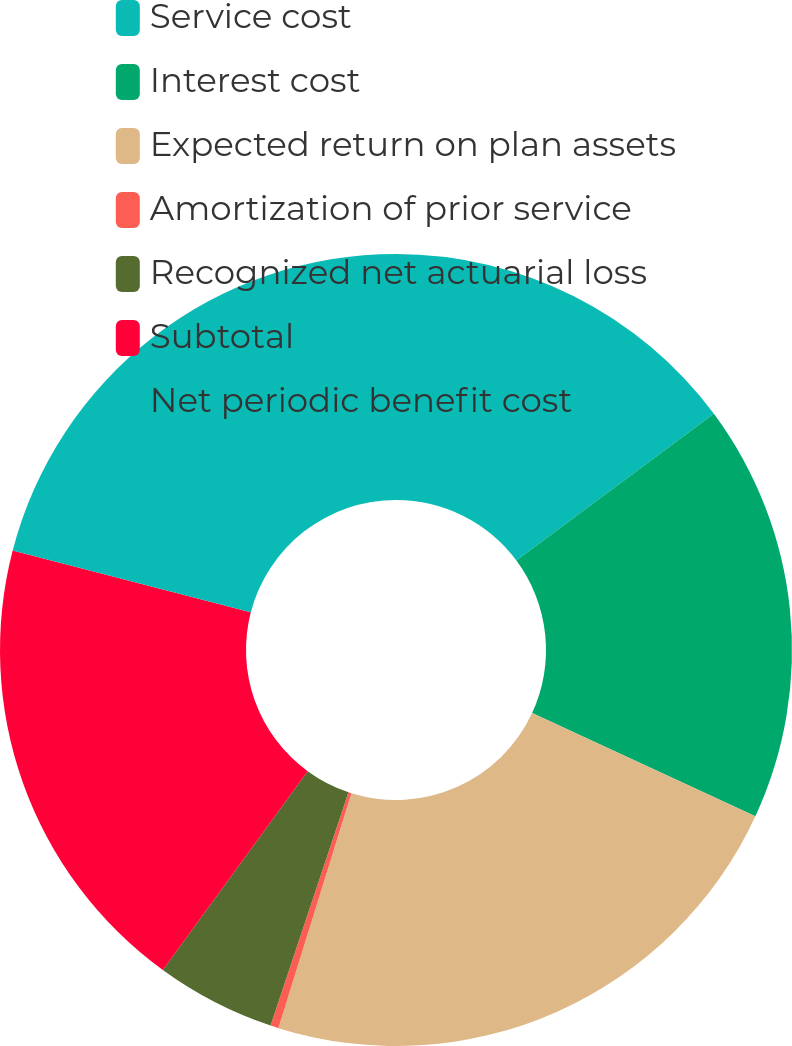Convert chart. <chart><loc_0><loc_0><loc_500><loc_500><pie_chart><fcel>Service cost<fcel>Interest cost<fcel>Expected return on plan assets<fcel>Amortization of prior service<fcel>Recognized net actuarial loss<fcel>Subtotal<fcel>Net periodic benefit cost<nl><fcel>14.83%<fcel>17.07%<fcel>22.9%<fcel>0.33%<fcel>4.89%<fcel>19.02%<fcel>20.96%<nl></chart> 